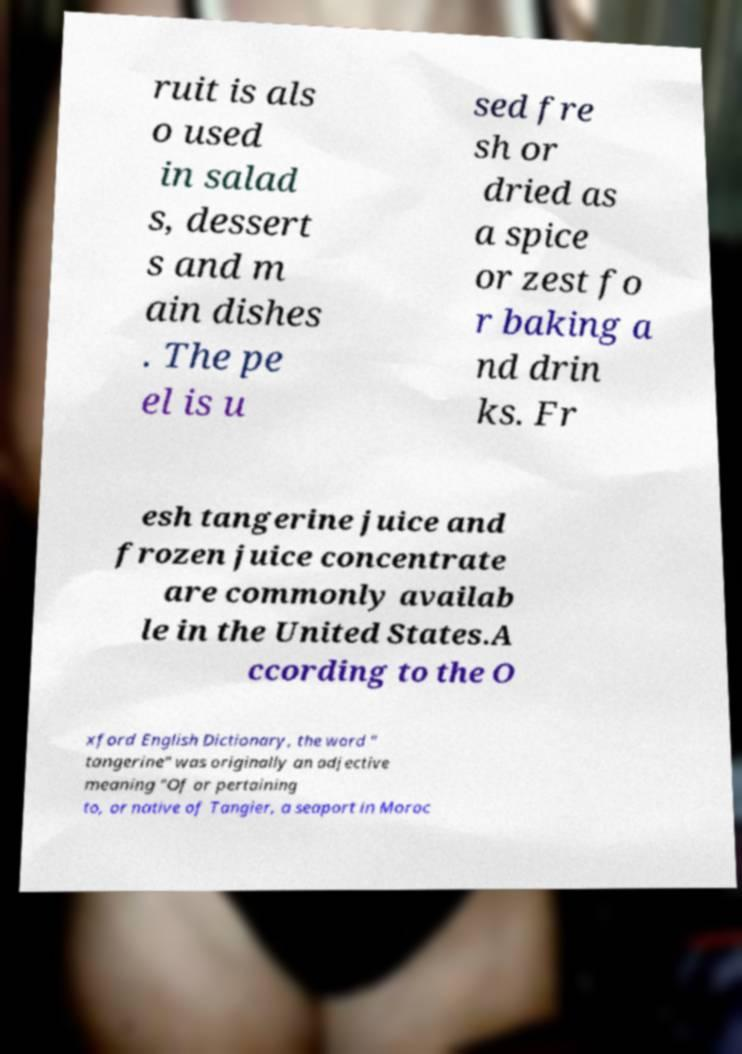Can you read and provide the text displayed in the image?This photo seems to have some interesting text. Can you extract and type it out for me? ruit is als o used in salad s, dessert s and m ain dishes . The pe el is u sed fre sh or dried as a spice or zest fo r baking a nd drin ks. Fr esh tangerine juice and frozen juice concentrate are commonly availab le in the United States.A ccording to the O xford English Dictionary, the word " tangerine" was originally an adjective meaning "Of or pertaining to, or native of Tangier, a seaport in Moroc 